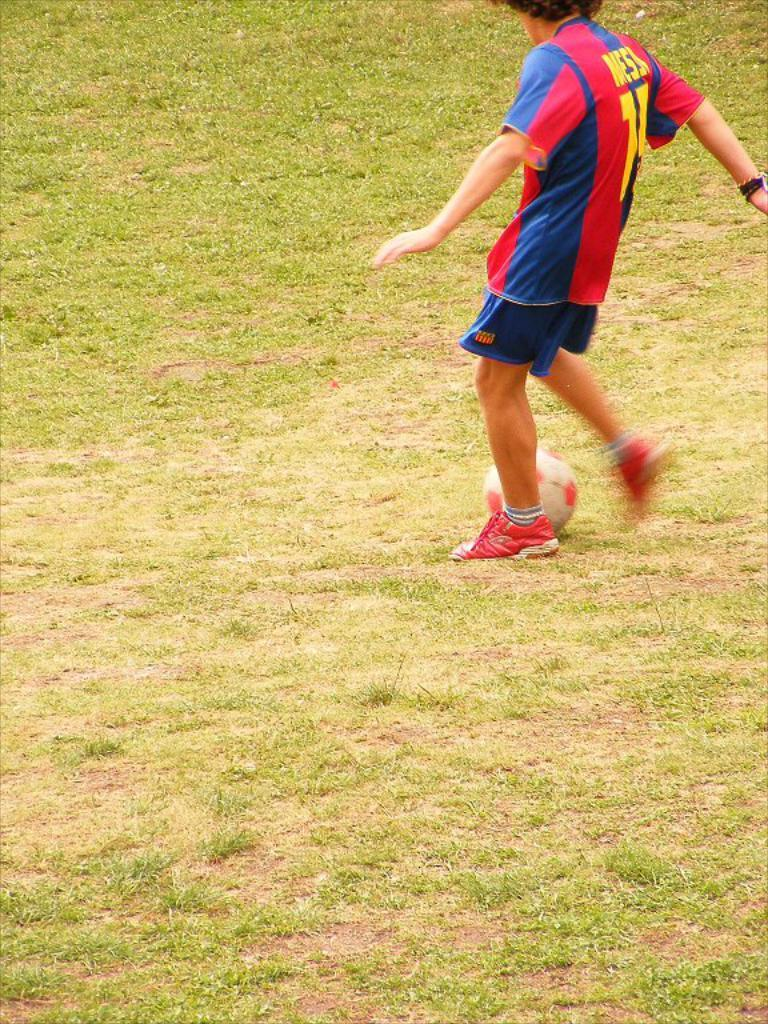<image>
Relay a brief, clear account of the picture shown. A man in a red, blue, and yellow shirt that says 15 and Messi on the back 